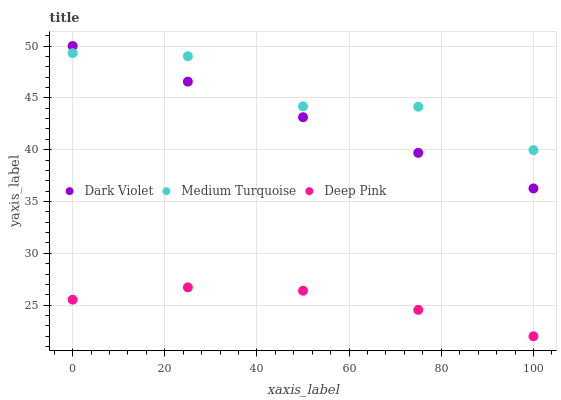Does Deep Pink have the minimum area under the curve?
Answer yes or no. Yes. Does Medium Turquoise have the maximum area under the curve?
Answer yes or no. Yes. Does Dark Violet have the minimum area under the curve?
Answer yes or no. No. Does Dark Violet have the maximum area under the curve?
Answer yes or no. No. Is Dark Violet the smoothest?
Answer yes or no. Yes. Is Medium Turquoise the roughest?
Answer yes or no. Yes. Is Medium Turquoise the smoothest?
Answer yes or no. No. Is Dark Violet the roughest?
Answer yes or no. No. Does Deep Pink have the lowest value?
Answer yes or no. Yes. Does Dark Violet have the lowest value?
Answer yes or no. No. Does Dark Violet have the highest value?
Answer yes or no. Yes. Does Medium Turquoise have the highest value?
Answer yes or no. No. Is Deep Pink less than Medium Turquoise?
Answer yes or no. Yes. Is Medium Turquoise greater than Deep Pink?
Answer yes or no. Yes. Does Dark Violet intersect Medium Turquoise?
Answer yes or no. Yes. Is Dark Violet less than Medium Turquoise?
Answer yes or no. No. Is Dark Violet greater than Medium Turquoise?
Answer yes or no. No. Does Deep Pink intersect Medium Turquoise?
Answer yes or no. No. 